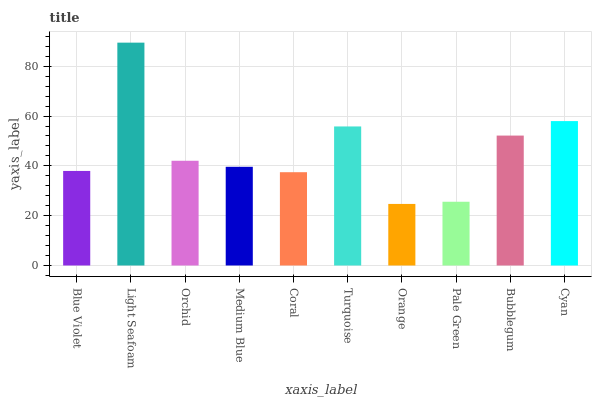Is Orange the minimum?
Answer yes or no. Yes. Is Light Seafoam the maximum?
Answer yes or no. Yes. Is Orchid the minimum?
Answer yes or no. No. Is Orchid the maximum?
Answer yes or no. No. Is Light Seafoam greater than Orchid?
Answer yes or no. Yes. Is Orchid less than Light Seafoam?
Answer yes or no. Yes. Is Orchid greater than Light Seafoam?
Answer yes or no. No. Is Light Seafoam less than Orchid?
Answer yes or no. No. Is Orchid the high median?
Answer yes or no. Yes. Is Medium Blue the low median?
Answer yes or no. Yes. Is Coral the high median?
Answer yes or no. No. Is Turquoise the low median?
Answer yes or no. No. 